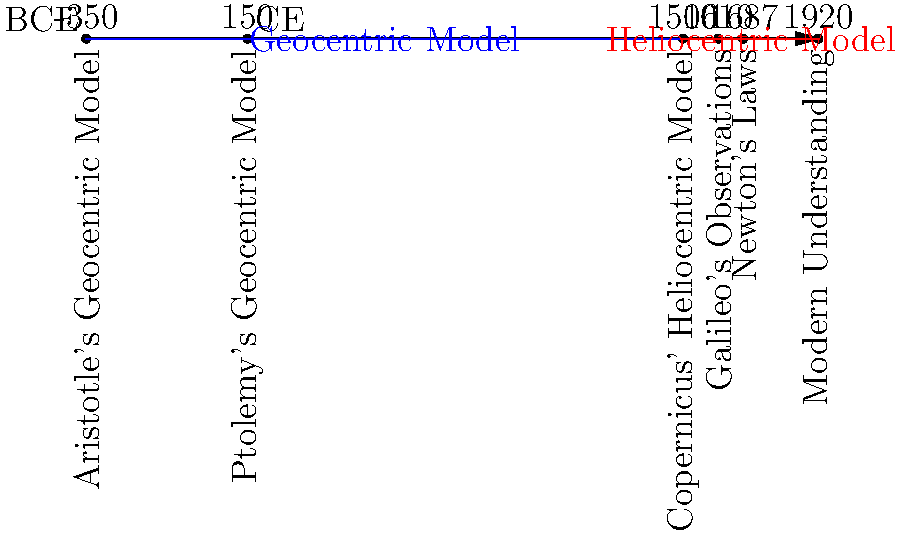Based on the timeline, which event marked the beginning of the shift from a geocentric to a heliocentric model of the solar system, and approximately how many years passed between this event and the establishment of Newton's Laws, which provided a mathematical foundation for the heliocentric model? To answer this question, we need to follow these steps:

1. Identify the event that marked the shift from geocentric to heliocentric model:
   Looking at the timeline, we can see that Copernicus' Heliocentric Model in 1500 CE marks the beginning of the shift from geocentric to heliocentric understanding.

2. Locate Newton's Laws on the timeline:
   Newton's Laws are shown to be established in 1687 CE.

3. Calculate the time difference:
   To find the number of years between these two events, we subtract:
   1687 CE - 1500 CE = 187 years

Therefore, Copernicus' Heliocentric Model in 1500 CE marked the beginning of the shift from a geocentric to a heliocentric model, and approximately 187 years passed before Newton's Laws provided a mathematical foundation for this model in 1687 CE.
Answer: Copernicus' Heliocentric Model; 187 years 